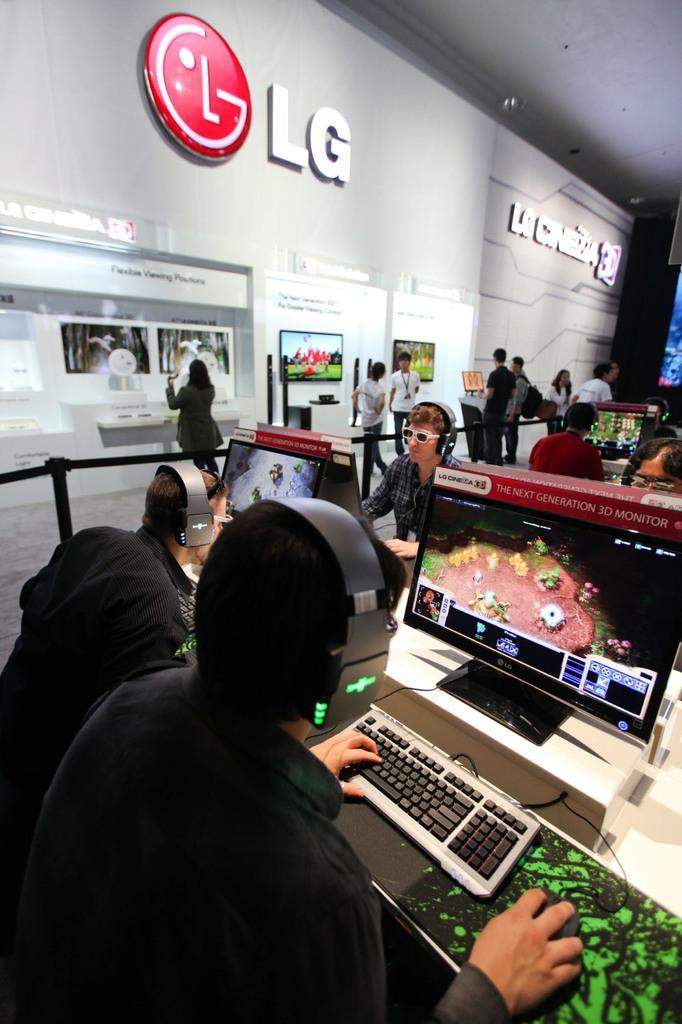Please provide a concise description of this image. In this picture we can see some people sitting and playing the games on the computer screen. Behind there are some people standing and looking to the "LG" naming board. 